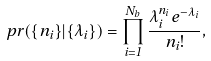<formula> <loc_0><loc_0><loc_500><loc_500>\ p r ( \{ n _ { i } \} | \{ \lambda _ { i } \} ) = \prod _ { i = 1 } ^ { N _ { b } } \frac { \lambda _ { i } ^ { n _ { i } } e ^ { - \lambda _ { i } } } { n _ { i } ! } ,</formula> 